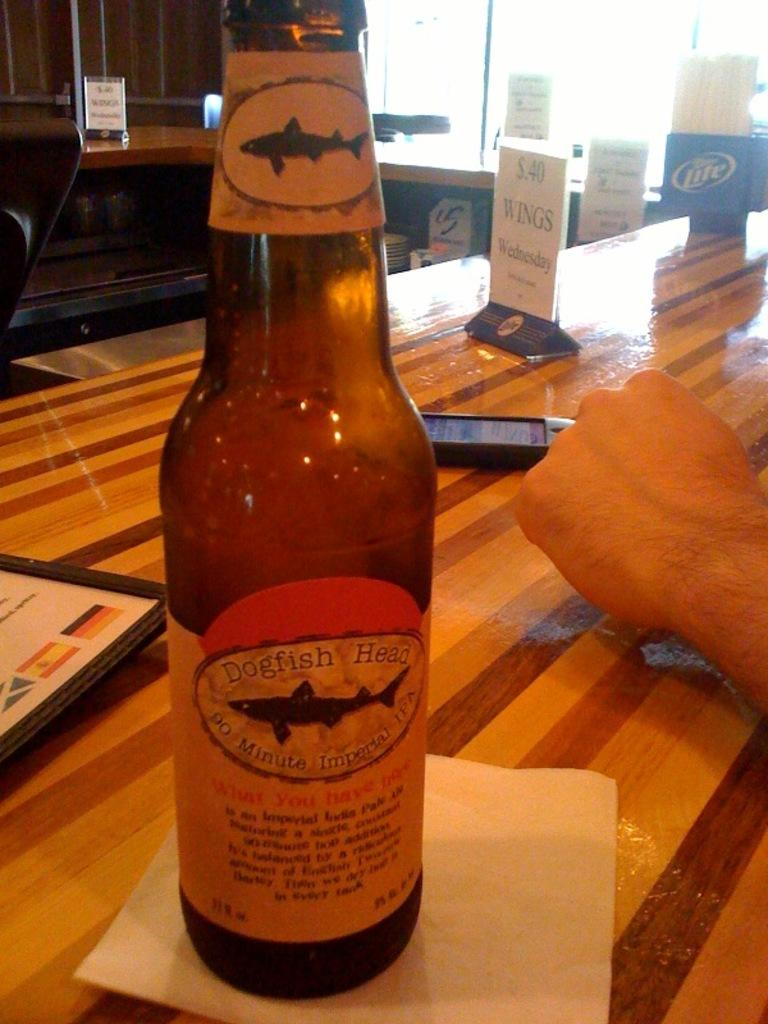<image>
Summarize the visual content of the image. A wood table with a bottle of beer titled Dogfish Head. 